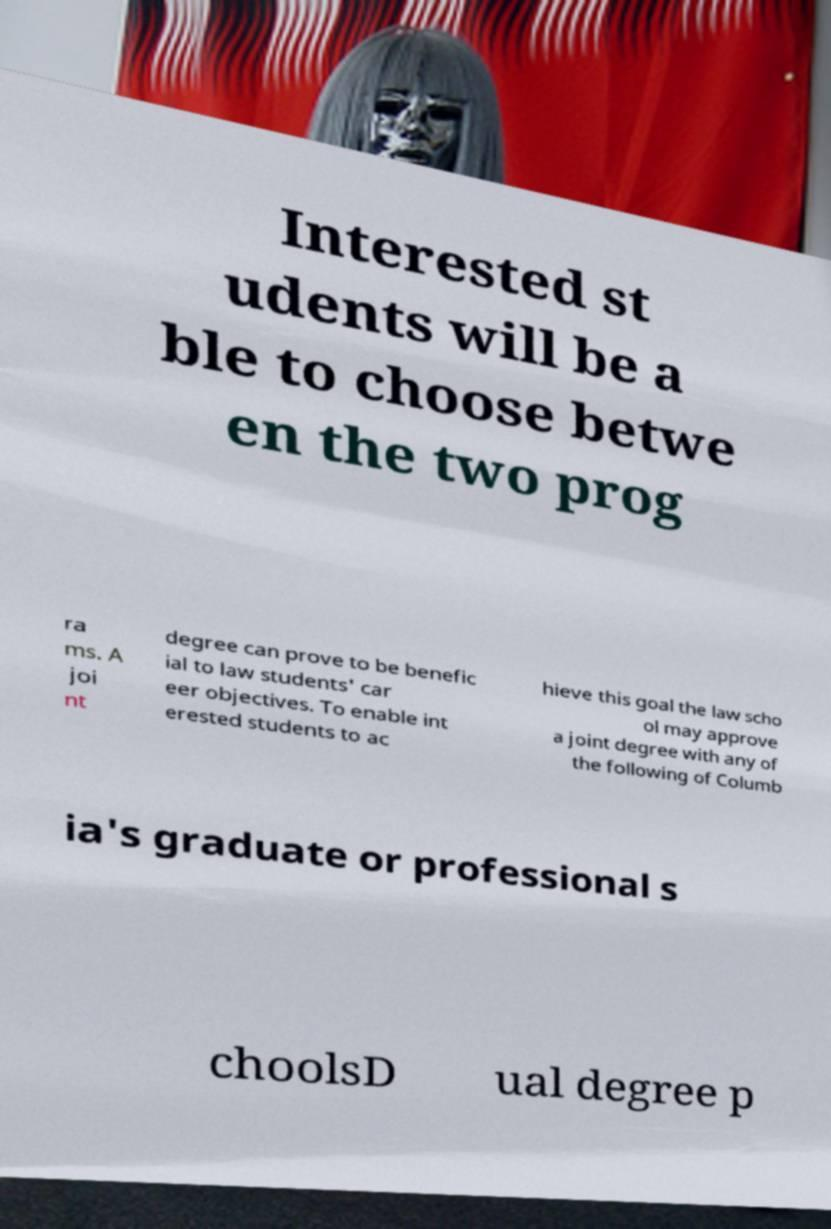Please identify and transcribe the text found in this image. Interested st udents will be a ble to choose betwe en the two prog ra ms. A joi nt degree can prove to be benefic ial to law students' car eer objectives. To enable int erested students to ac hieve this goal the law scho ol may approve a joint degree with any of the following of Columb ia's graduate or professional s choolsD ual degree p 